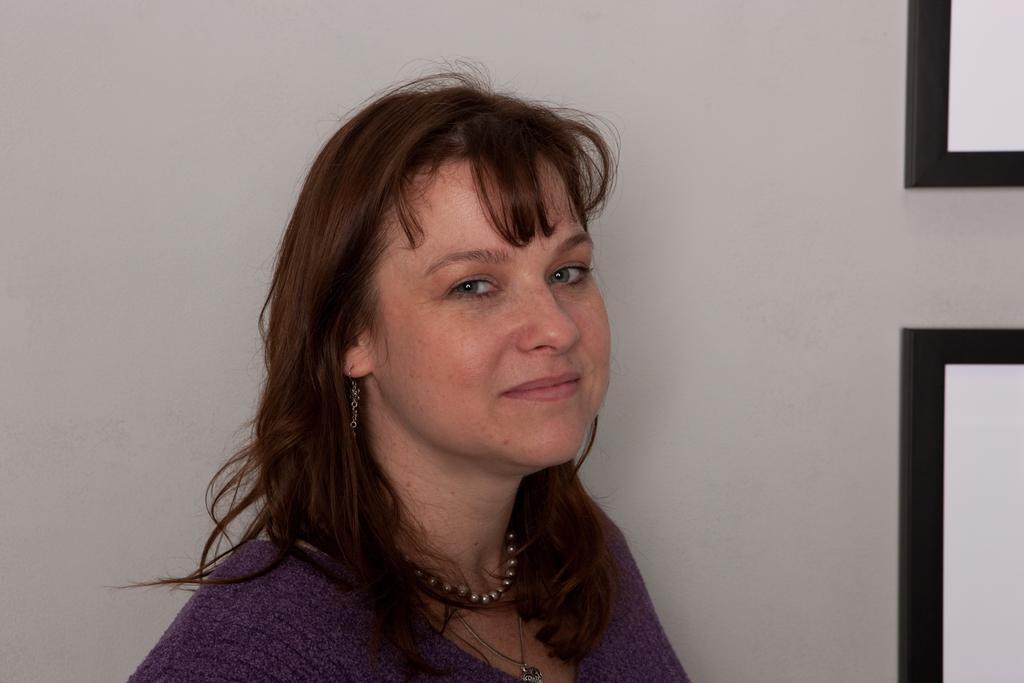Describe this image in one or two sentences. In this picture we can observe a woman. She is wearing violet color dress and she is smiling. In the background there is a white color wall. 